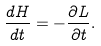Convert formula to latex. <formula><loc_0><loc_0><loc_500><loc_500>\frac { d H } { d t } = - \frac { \partial L } { \partial t } .</formula> 